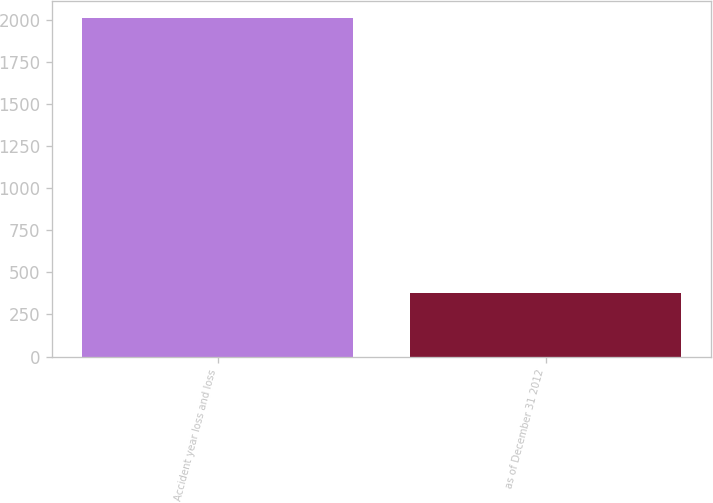Convert chart to OTSL. <chart><loc_0><loc_0><loc_500><loc_500><bar_chart><fcel>Accident year loss and loss<fcel>as of December 31 2012<nl><fcel>2012<fcel>375<nl></chart> 